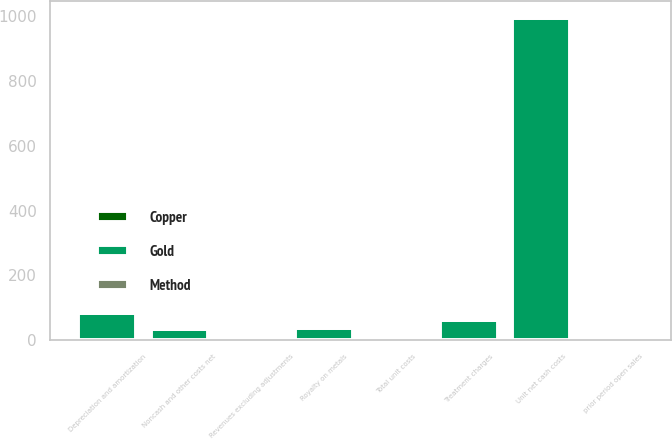Convert chart to OTSL. <chart><loc_0><loc_0><loc_500><loc_500><stacked_bar_chart><ecel><fcel>Revenues excluding adjustments<fcel>Treatment charges<fcel>Royalty on metals<fcel>Unit net cash costs<fcel>Depreciation and amortization<fcel>Noncash and other costs net<fcel>Total unit costs<fcel>prior period open sales<nl><fcel>Copper<fcel>3.58<fcel>0.21<fcel>0.13<fcel>1.24<fcel>0.3<fcel>0.11<fcel>1.65<fcel>0.02<nl><fcel>Method<fcel>3.58<fcel>0.13<fcel>0.08<fcel>2.14<fcel>0.18<fcel>0.07<fcel>2.39<fcel>0.02<nl><fcel>Gold<fcel>1.445<fcel>61<fcel>38<fcel>993<fcel>85<fcel>33<fcel>1.445<fcel>3<nl></chart> 